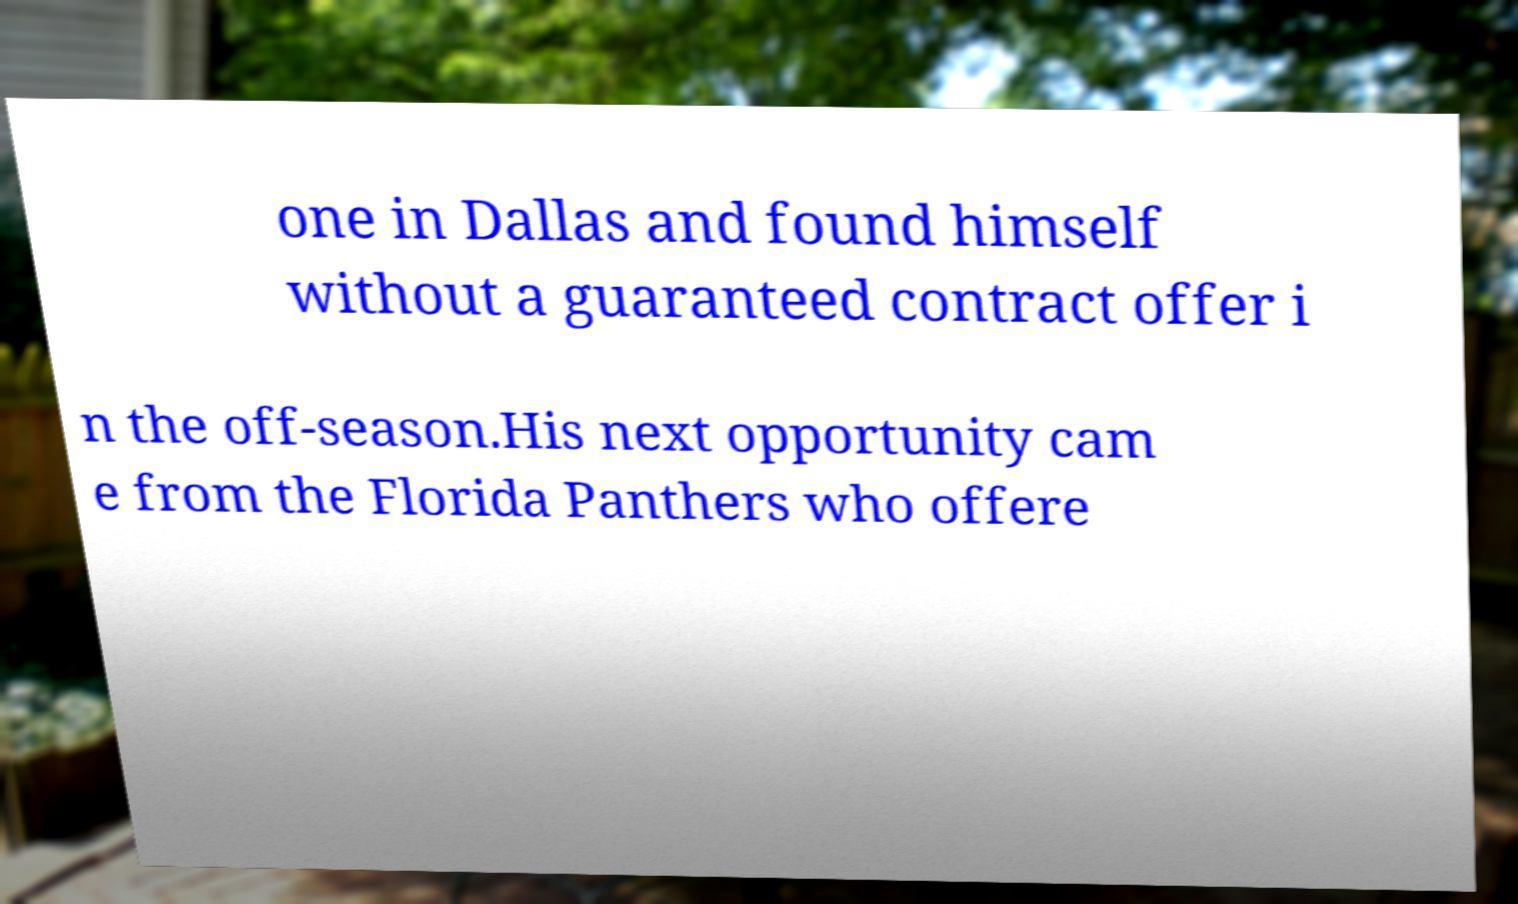Please identify and transcribe the text found in this image. one in Dallas and found himself without a guaranteed contract offer i n the off-season.His next opportunity cam e from the Florida Panthers who offere 